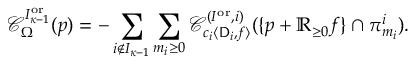<formula> <loc_0><loc_0><loc_500><loc_500>\mathcal { C } _ { \Omega } ^ { I _ { { \kappa } - 1 } ^ { o r } } ( p ) = - \sum _ { i \notin I _ { { \kappa } - 1 } } \sum _ { m _ { i } \geq 0 } \mathcal { C } _ { c _ { i } \langle D _ { i } , f \rangle } ^ { ( I ^ { o r } , i ) } ( \{ p + \mathbb { R } _ { \geq 0 } f \} \cap \pi _ { m _ { i } } ^ { i } ) .</formula> 